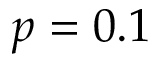Convert formula to latex. <formula><loc_0><loc_0><loc_500><loc_500>p = 0 . 1</formula> 